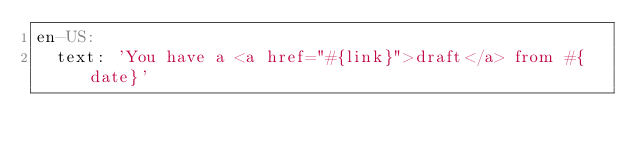Convert code to text. <code><loc_0><loc_0><loc_500><loc_500><_YAML_>en-US:
  text: 'You have a <a href="#{link}">draft</a> from #{date}'
</code> 